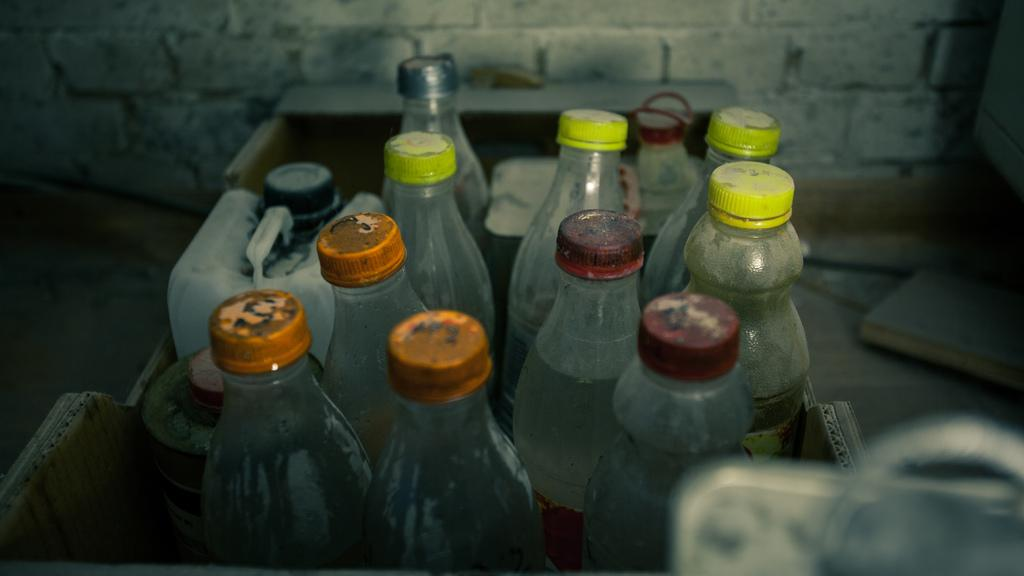What types of containers are visible in the image? There are bottles and cans in the image. How are the bottles and cans arranged in the image? The bottles and cans are placed in a basket. What can be seen in the background of the image? There is a wall in the background of the image. What type of grape is being used to play the drum in the image? There is no drum or grape present in the image; it only features bottles and cans in a basket with a wall in the background. 